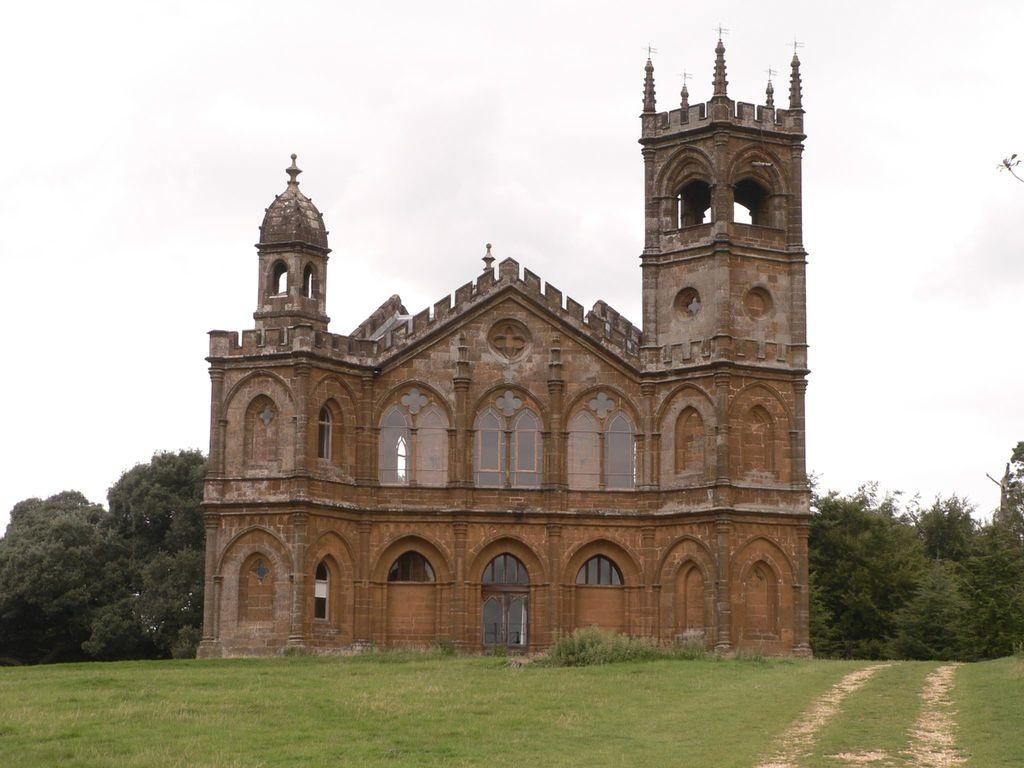What is the main structure in the center of the image? There is a building in the center of the image. What type of ground is visible at the bottom of the image? There is grass at the bottom of the image. What can be seen in the background of the image? There are trees in the background of the image. What is visible at the top of the image? The sky is visible at the top of the image. How many boats are visible in the image? There are no boats present in the image. What type of apparel is the bed wearing in the image? There is no bed present in the image, and therefore no apparel can be associated with it. 